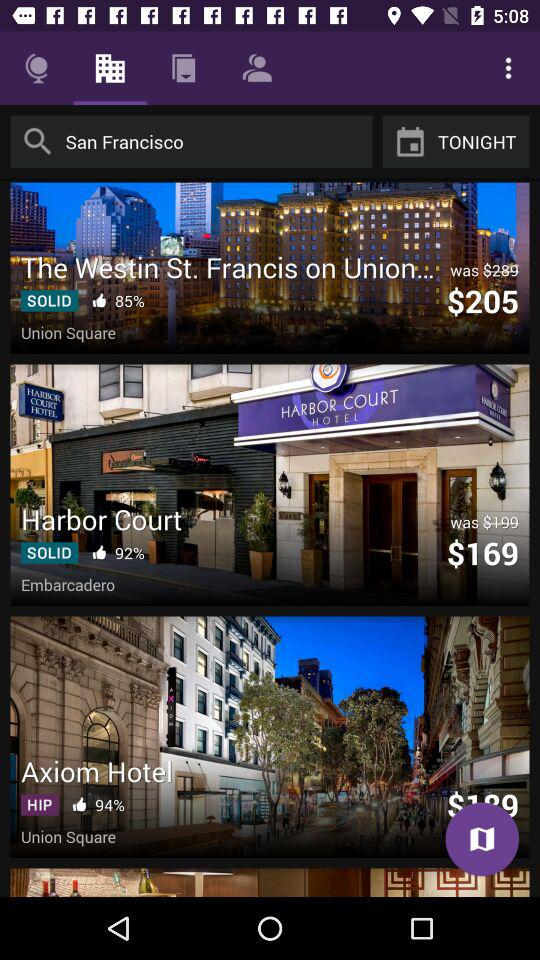Which hotel would be suitable for someone looking for a historic and elegant stay? 'The Westin St. Francis' would be perfect for someone looking for a historic and elegant stay. This iconic hotel on Union Square has a grand presence and is known for its luxurious offerings and classic charm. It's also situated in a prime location for exploring the cultural heart of San Francisco. 